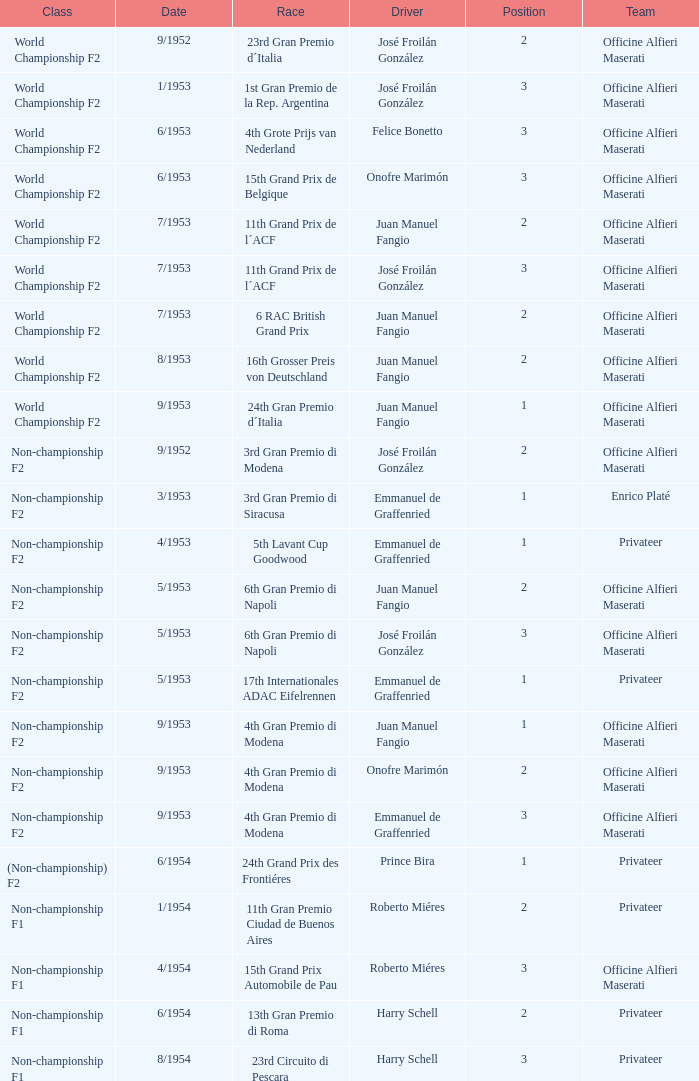Which driver is associated with the officine alfieri maserati team, competes in the non-championship f2 class, has a position of 2, and has a date of september 1952? José Froilán González. 